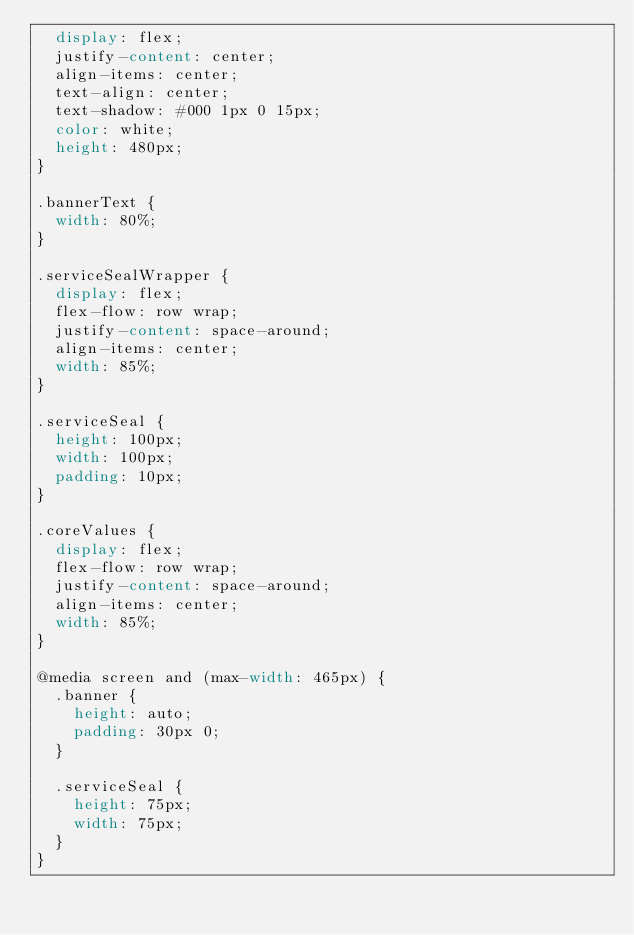Convert code to text. <code><loc_0><loc_0><loc_500><loc_500><_CSS_>  display: flex;
  justify-content: center;
  align-items: center;
  text-align: center;
  text-shadow: #000 1px 0 15px;
  color: white;
  height: 480px;
}

.bannerText {
  width: 80%;
}

.serviceSealWrapper {
  display: flex;
  flex-flow: row wrap;
  justify-content: space-around;
  align-items: center;
  width: 85%;
}

.serviceSeal {
  height: 100px;
  width: 100px;
  padding: 10px;
}

.coreValues {
  display: flex;
  flex-flow: row wrap;
  justify-content: space-around;
  align-items: center;
  width: 85%;
}

@media screen and (max-width: 465px) {
  .banner {
    height: auto;
    padding: 30px 0;
  }

  .serviceSeal {
    height: 75px;
    width: 75px;
  }
}
</code> 